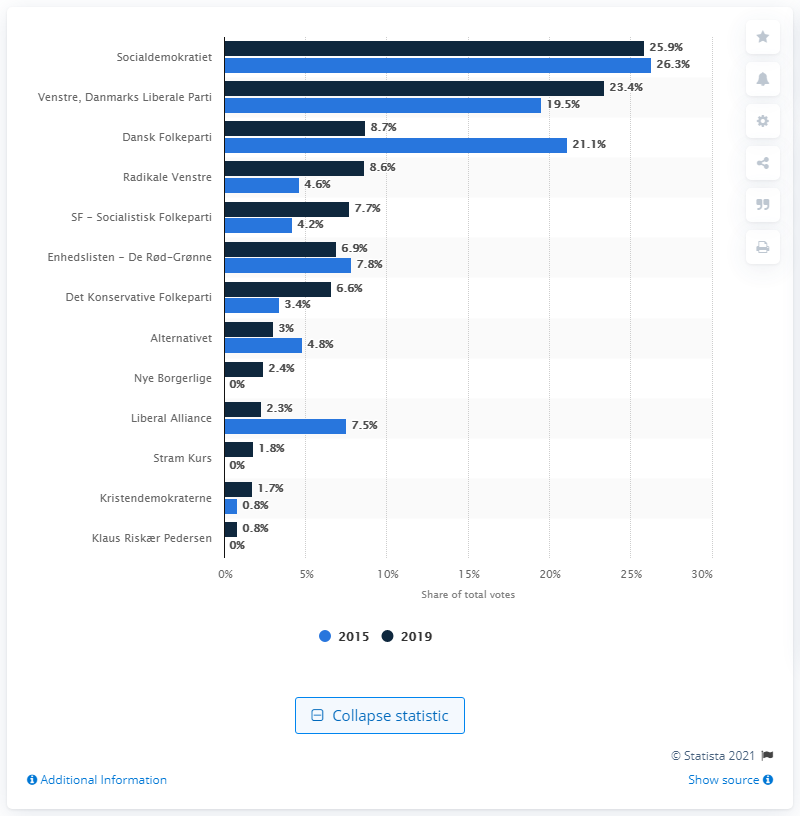Outline some significant characteristics in this image. Dansk Folkeparti received 8.7% of the votes in 2019. 